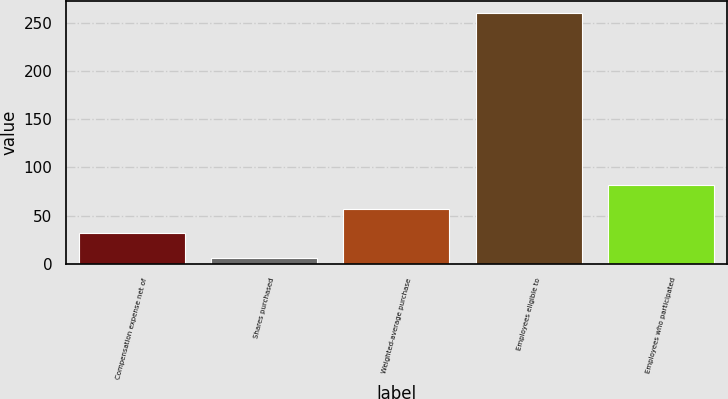Convert chart to OTSL. <chart><loc_0><loc_0><loc_500><loc_500><bar_chart><fcel>Compensation expense net of<fcel>Shares purchased<fcel>Weighted-average purchase<fcel>Employees eligible to<fcel>Employees who participated<nl><fcel>31.54<fcel>6.16<fcel>56.92<fcel>260<fcel>82.3<nl></chart> 